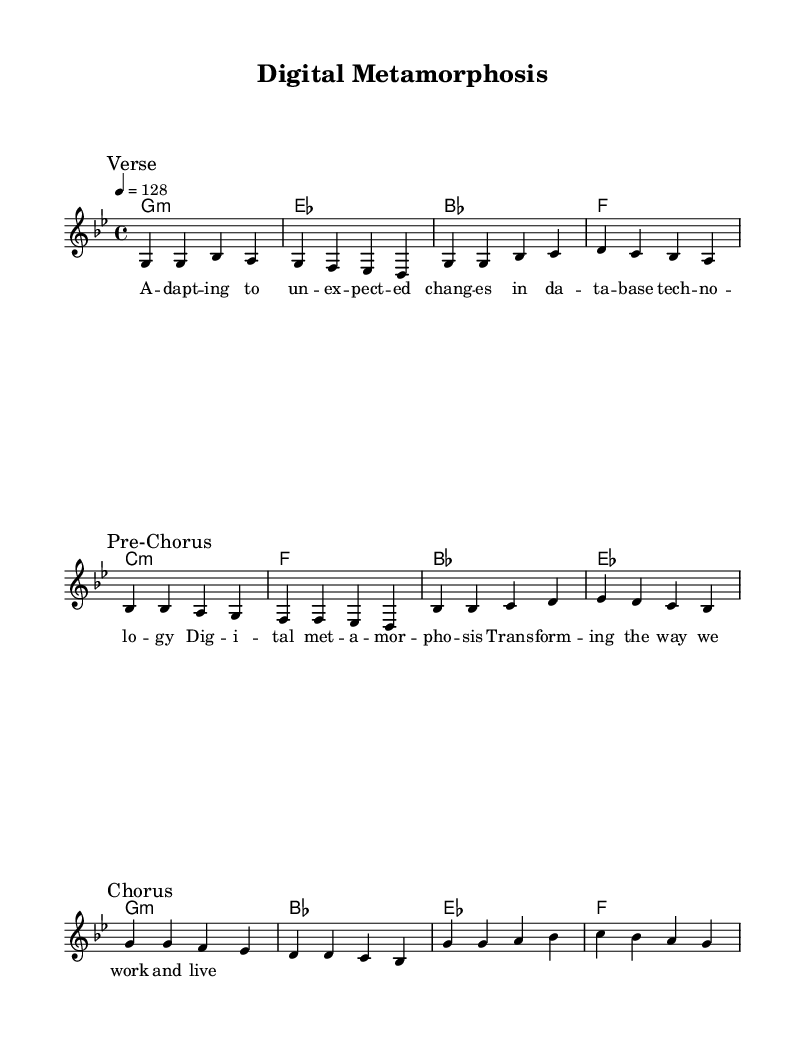What is the key signature of this music? The key signature shows one flat on the staff, indicating that the music is in G minor.
Answer: G minor What is the time signature of this music? The time signature appears as a fraction "4/4", meaning there are four beats in a measure and the quarter note gets one beat.
Answer: 4/4 What is the tempo marking of this piece? The tempo marking reads "4 = 128", indicating that there are 128 beats per minute with a quarter note as the unit.
Answer: 128 How many sections are in the melody? The melody has three distinct sections marked: Verse, Pre-Chorus, and Chorus, which indicate a structured format typical in K-Pop songs.
Answer: Three What is the first chord of the harmonies? The first chord, indicated in the chord names at the beginning of the score, is G minor, which sets the tonal foundation for the piece.
Answer: G minor Which lyrical theme reflects the collaboration in this song? The lyrics highlight adapting to unexpected changes in database technology, representing the theme of adjustments due to advancements in technology.
Answer: Adapting to unexpected changes How does this piece embody elements typical of K-Pop? This piece features a structured arrangement with distinct sections (Verse, Pre-Chorus, Chorus) and a modern lyrical theme indicative of K-Pop collaborations addressing technological changes.
Answer: Structured arrangement & modern theme 